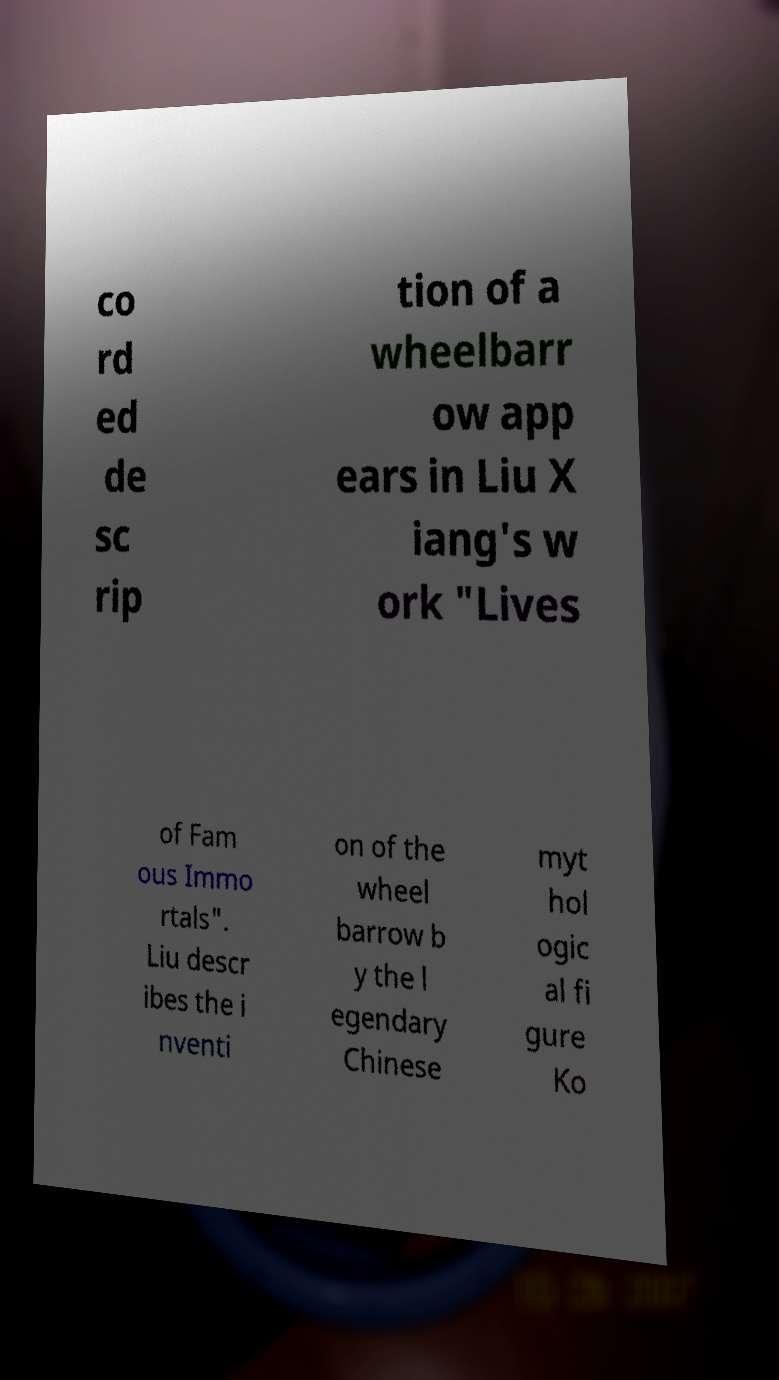Could you assist in decoding the text presented in this image and type it out clearly? co rd ed de sc rip tion of a wheelbarr ow app ears in Liu X iang's w ork "Lives of Fam ous Immo rtals". Liu descr ibes the i nventi on of the wheel barrow b y the l egendary Chinese myt hol ogic al fi gure Ko 